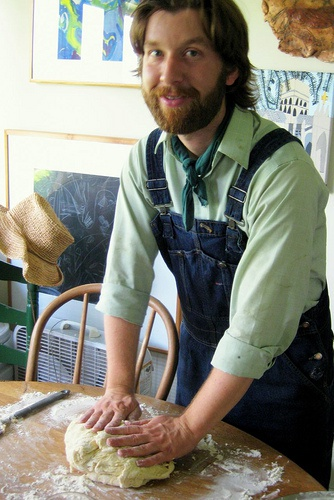Describe the objects in this image and their specific colors. I can see people in ivory, black, gray, and darkgray tones, dining table in ivory, darkgray, maroon, lightgray, and tan tones, chair in ivory, darkgray, gray, lightgray, and black tones, and spoon in ivory, gray, darkgray, black, and lightgray tones in this image. 